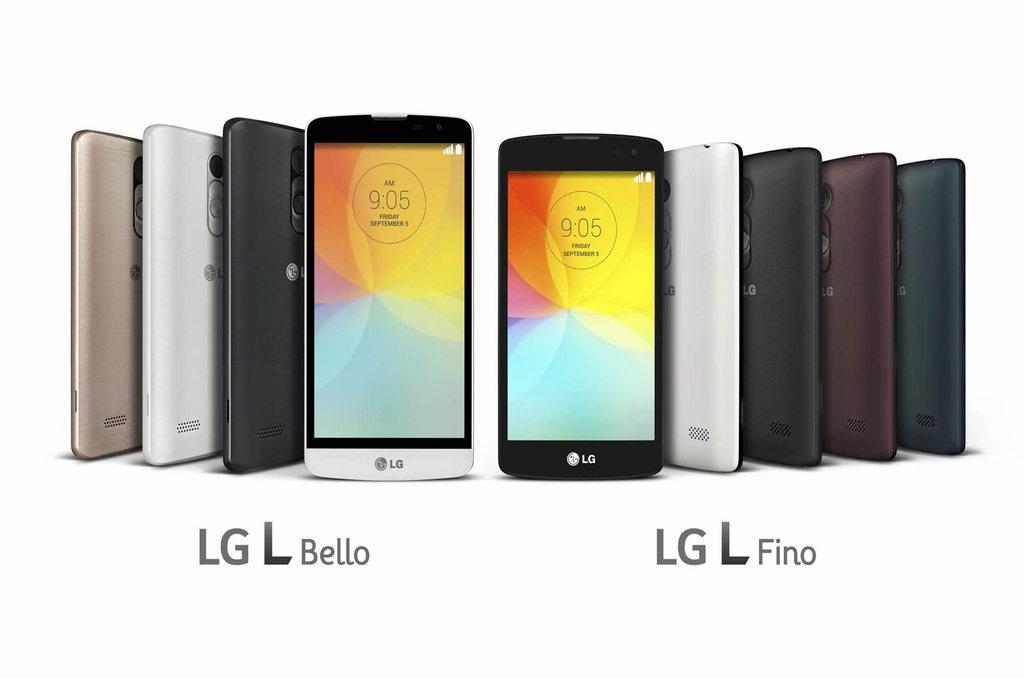<image>
Offer a succinct explanation of the picture presented. many phones with the names LG below them 